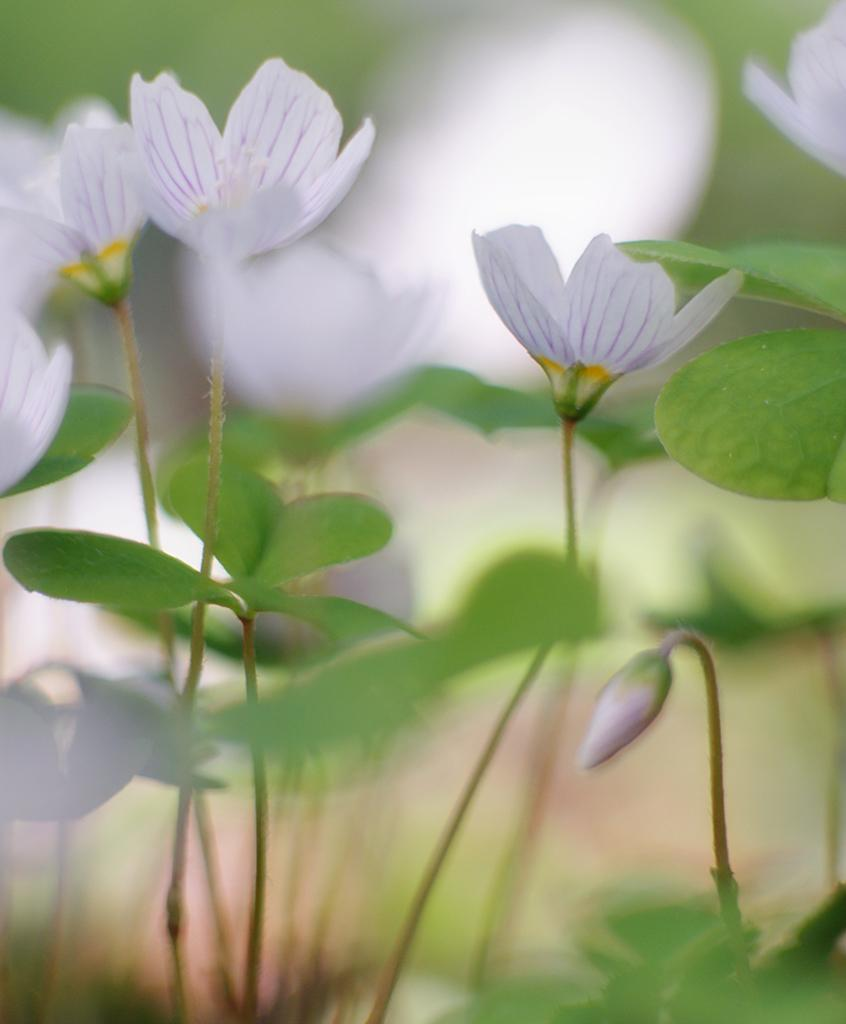What type of flowers can be seen in the image? There are white flowers in the image. What else can be seen in the image besides the flowers? There are leaves in the image. What type of flight is depicted in the image? There is no flight depicted in the image; it features white flowers and leaves. What was the artist's afterthought when creating the image? The provided facts do not give any information about the artist's intentions or afterthoughts, so we cannot answer this question. 